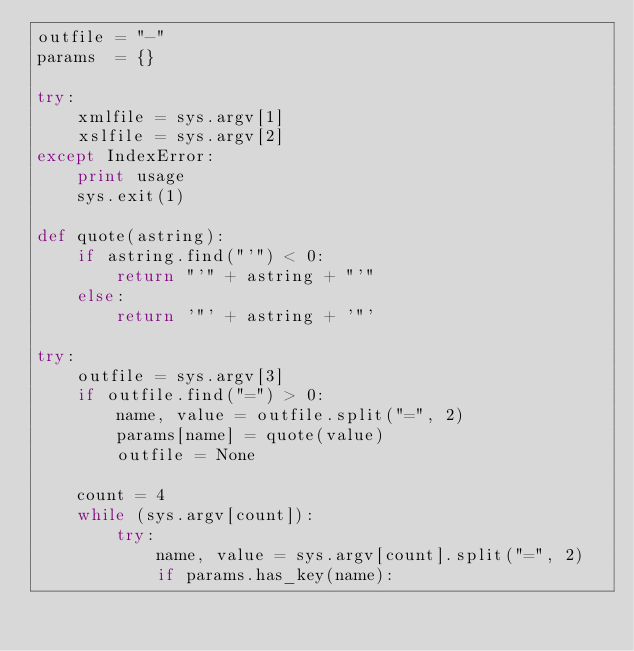Convert code to text. <code><loc_0><loc_0><loc_500><loc_500><_Python_>outfile = "-"
params  = {}

try:
    xmlfile = sys.argv[1]
    xslfile = sys.argv[2]
except IndexError:
    print usage
    sys.exit(1)

def quote(astring):
    if astring.find("'") < 0:
        return "'" + astring + "'"
    else:
        return '"' + astring + '"'

try:
    outfile = sys.argv[3]
    if outfile.find("=") > 0:
        name, value = outfile.split("=", 2)
        params[name] = quote(value)
        outfile = None

    count = 4
    while (sys.argv[count]):
        try:
            name, value = sys.argv[count].split("=", 2)
            if params.has_key(name):</code> 